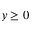Convert formula to latex. <formula><loc_0><loc_0><loc_500><loc_500>y \geq 0</formula> 